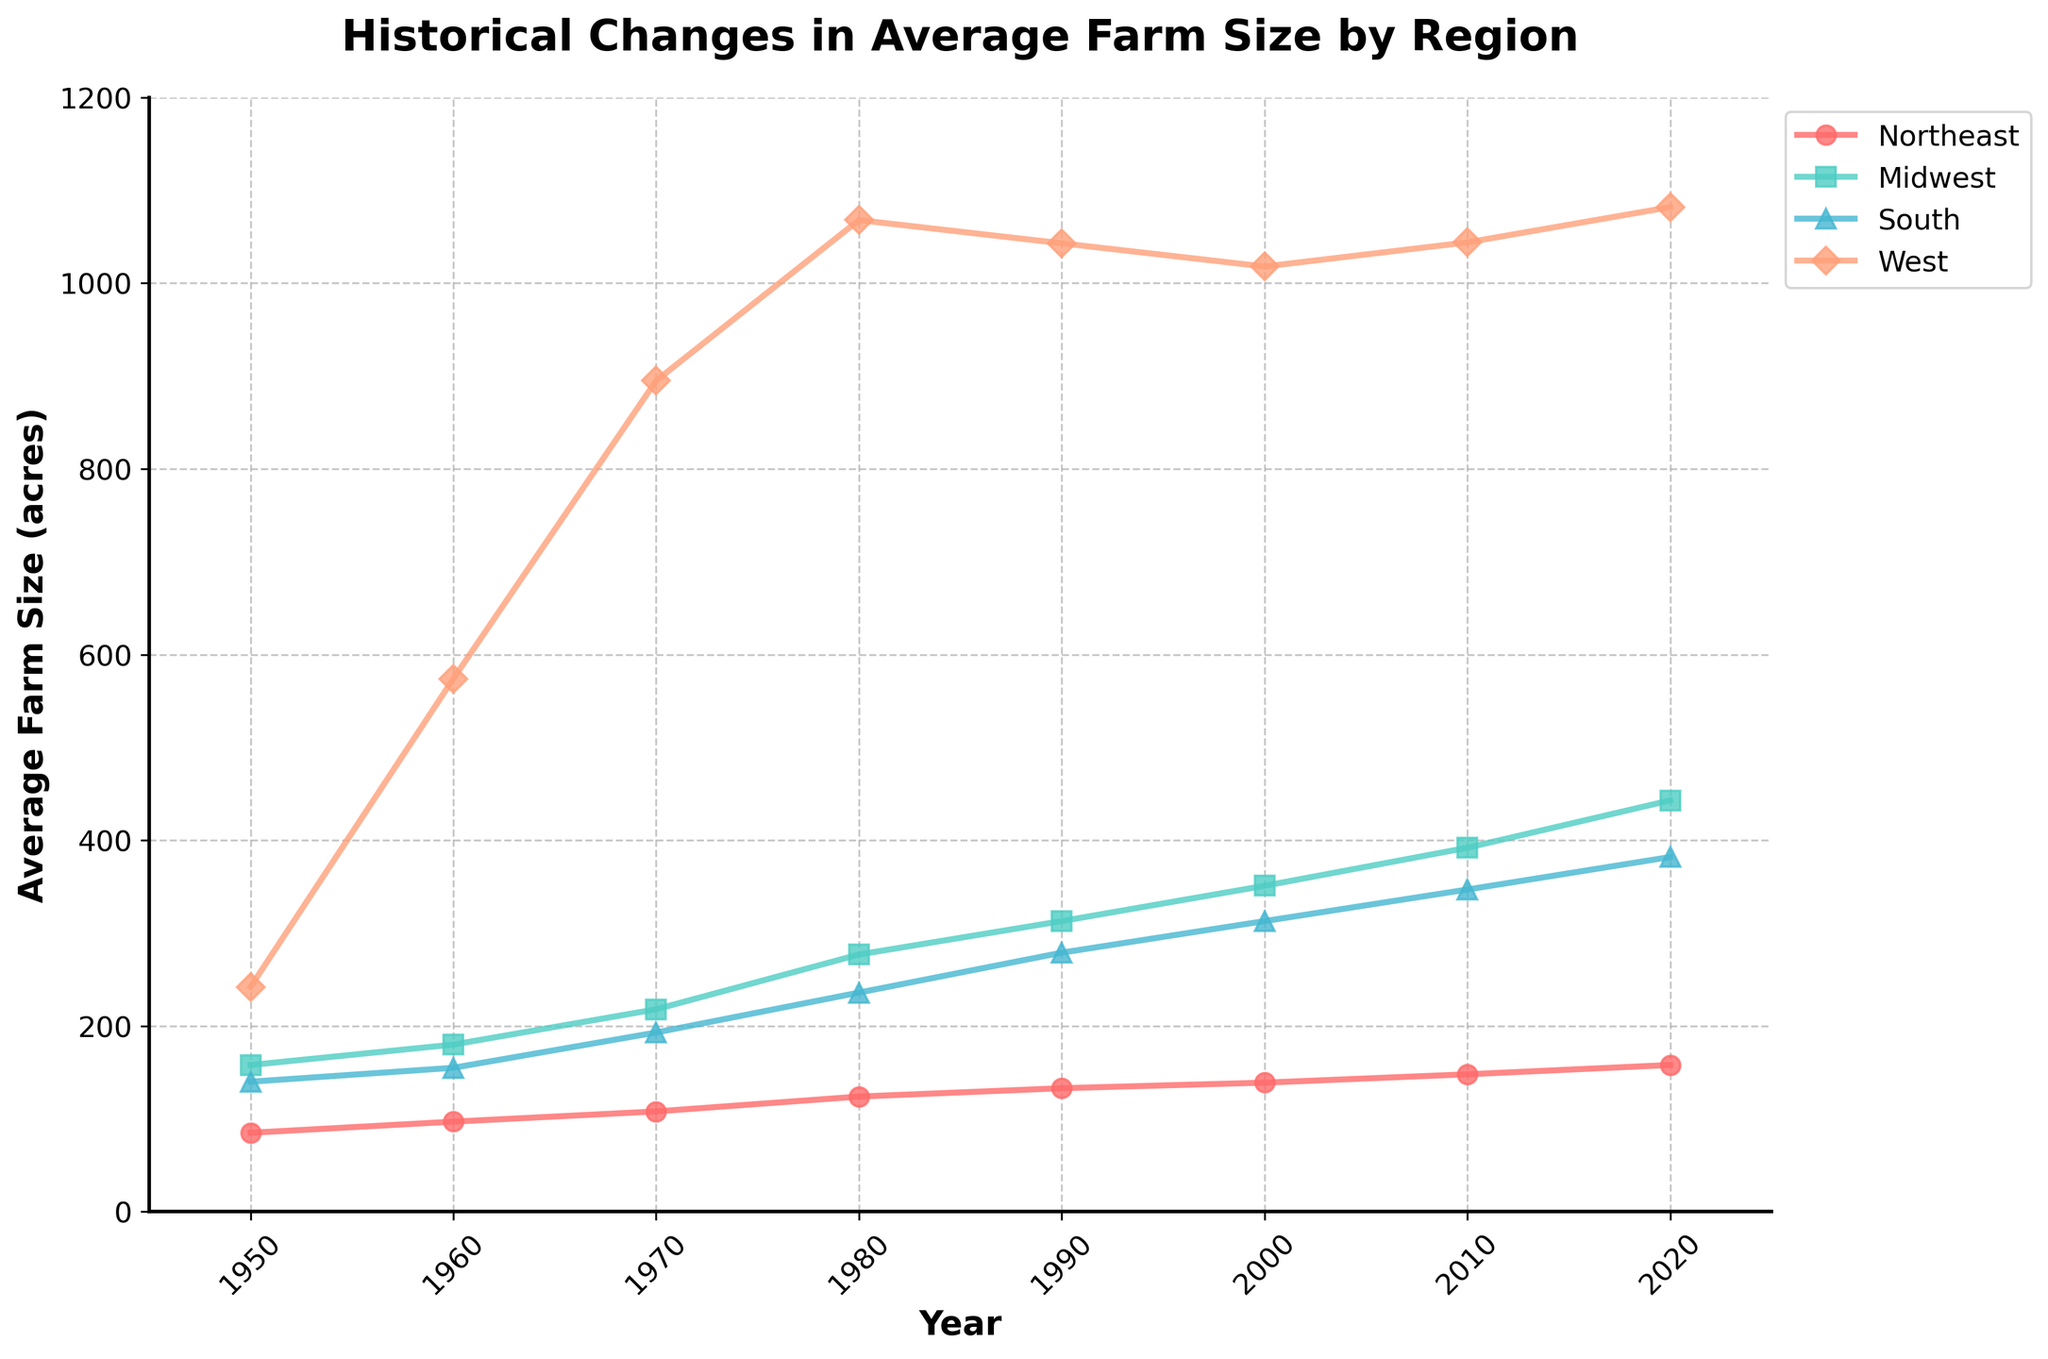what is the trend in the average farm size in the Midwest region from 1950 to 2020? The Midwest shows a steady increase in average farm size from 1950 to 2020. Starting at 158 acres in 1950, the size increases almost every decade, reaching 443 acres in 2020.
Answer: Steady increase What region has the largest average farm size in 1980? In 1980, the West has the largest average farm size. From the figure, it's clear that the West's line is significantly higher than the other regions around 1980, at 1068 acres.
Answer: West Compare the increase in average farm size from 1950 to 2020 between the Northeast and the South. In 1950, the average farm size in the Northeast was 85 acres, and in 2020, it was 158 acres, making an increase of 73 acres. In the South, it started at 140 acres in 1950 and increased to 382 acres in 2020, making an increase of 242 acres.
Answer: South increased more Which years show the largest jump in average farm size for the West region? The largest jump in the average farm size for the West region occurs between 1960 and 1970 and between 1970 and 1980. The farm size jumps from 574 to 895 acres (an increase of 321 acres) between 1960 and 1970. Then, from 895 to 1068 acres (an increase of 173 acres) between 1970 and 1980.
Answer: 1960-1970 and 1970-1980 How did the average farm size in the South region change from 1990 to 2010? The average farm size in the South increased from 279 acres in 1990 to 347 acres in 2010. The increase is 68 acres over this period.
Answer: Increase by 68 acres Which region has the slowest growth rate in average farm size over the entire period? By examining the slopes of the lines for each region, the Northeast shows the most gradual slope, indicating the slowest growth rate in average farm size over the period from 1950 to 2020.
Answer: Northeast What is the difference in average farm size between the West and the South in 2000? In 2000, the average farm size in the West is 1018 acres, and in the South, it is 313 acres. The difference between them is 1018 - 313 = 705 acres.
Answer: 705 acres Identify the region that had a consistent increase in farm size every decade. The Midwest had a consistent increase every decade. Looking at the plot, the farm size line for the Midwest consistently rises, without any decade showing a decrease.
Answer: Midwest 